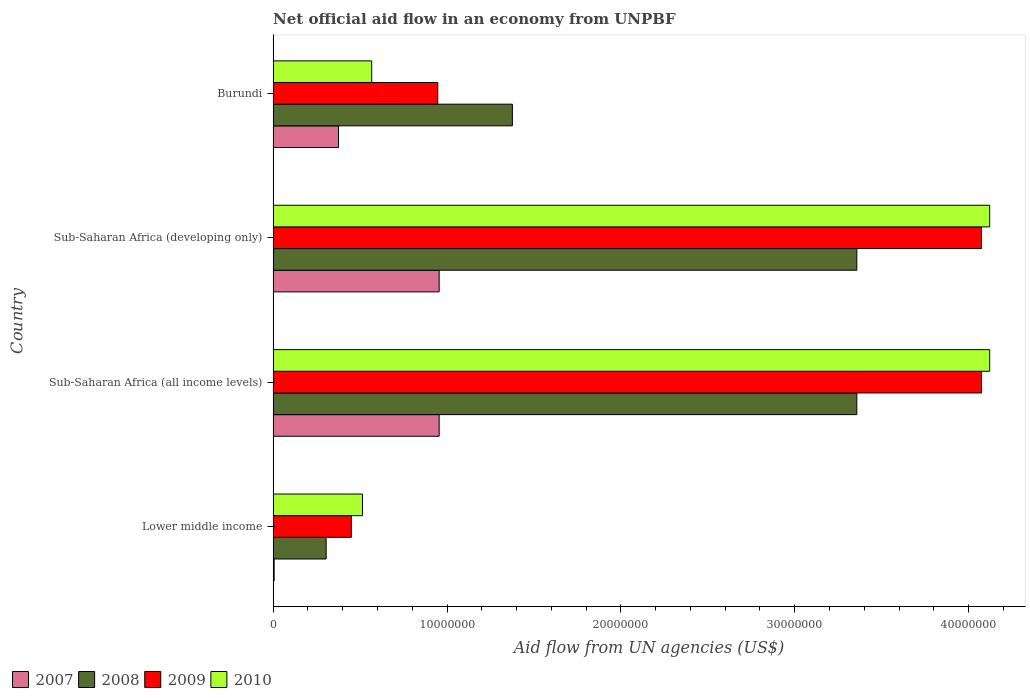How many different coloured bars are there?
Your answer should be compact. 4. How many groups of bars are there?
Offer a very short reply. 4. How many bars are there on the 2nd tick from the bottom?
Ensure brevity in your answer.  4. What is the label of the 1st group of bars from the top?
Ensure brevity in your answer.  Burundi. In how many cases, is the number of bars for a given country not equal to the number of legend labels?
Offer a very short reply. 0. What is the net official aid flow in 2010 in Lower middle income?
Your answer should be compact. 5.14e+06. Across all countries, what is the maximum net official aid flow in 2007?
Your response must be concise. 9.55e+06. Across all countries, what is the minimum net official aid flow in 2009?
Make the answer very short. 4.50e+06. In which country was the net official aid flow in 2008 maximum?
Offer a very short reply. Sub-Saharan Africa (all income levels). In which country was the net official aid flow in 2008 minimum?
Give a very brief answer. Lower middle income. What is the total net official aid flow in 2009 in the graph?
Make the answer very short. 9.54e+07. What is the difference between the net official aid flow in 2008 in Burundi and that in Lower middle income?
Offer a terse response. 1.07e+07. What is the difference between the net official aid flow in 2008 in Sub-Saharan Africa (developing only) and the net official aid flow in 2010 in Lower middle income?
Provide a succinct answer. 2.84e+07. What is the average net official aid flow in 2009 per country?
Give a very brief answer. 2.39e+07. What is the difference between the net official aid flow in 2008 and net official aid flow in 2009 in Sub-Saharan Africa (all income levels)?
Offer a very short reply. -7.17e+06. In how many countries, is the net official aid flow in 2010 greater than 34000000 US$?
Provide a short and direct response. 2. What is the ratio of the net official aid flow in 2010 in Sub-Saharan Africa (all income levels) to that in Sub-Saharan Africa (developing only)?
Keep it short and to the point. 1. What is the difference between the highest and the lowest net official aid flow in 2007?
Offer a terse response. 9.49e+06. How many countries are there in the graph?
Keep it short and to the point. 4. Where does the legend appear in the graph?
Give a very brief answer. Bottom left. How many legend labels are there?
Provide a short and direct response. 4. What is the title of the graph?
Your answer should be very brief. Net official aid flow in an economy from UNPBF. Does "1979" appear as one of the legend labels in the graph?
Your answer should be very brief. No. What is the label or title of the X-axis?
Ensure brevity in your answer.  Aid flow from UN agencies (US$). What is the Aid flow from UN agencies (US$) in 2007 in Lower middle income?
Provide a short and direct response. 6.00e+04. What is the Aid flow from UN agencies (US$) in 2008 in Lower middle income?
Your answer should be compact. 3.05e+06. What is the Aid flow from UN agencies (US$) of 2009 in Lower middle income?
Your response must be concise. 4.50e+06. What is the Aid flow from UN agencies (US$) in 2010 in Lower middle income?
Provide a short and direct response. 5.14e+06. What is the Aid flow from UN agencies (US$) in 2007 in Sub-Saharan Africa (all income levels)?
Offer a terse response. 9.55e+06. What is the Aid flow from UN agencies (US$) in 2008 in Sub-Saharan Africa (all income levels)?
Make the answer very short. 3.36e+07. What is the Aid flow from UN agencies (US$) of 2009 in Sub-Saharan Africa (all income levels)?
Offer a very short reply. 4.07e+07. What is the Aid flow from UN agencies (US$) in 2010 in Sub-Saharan Africa (all income levels)?
Give a very brief answer. 4.12e+07. What is the Aid flow from UN agencies (US$) in 2007 in Sub-Saharan Africa (developing only)?
Give a very brief answer. 9.55e+06. What is the Aid flow from UN agencies (US$) of 2008 in Sub-Saharan Africa (developing only)?
Give a very brief answer. 3.36e+07. What is the Aid flow from UN agencies (US$) in 2009 in Sub-Saharan Africa (developing only)?
Ensure brevity in your answer.  4.07e+07. What is the Aid flow from UN agencies (US$) in 2010 in Sub-Saharan Africa (developing only)?
Ensure brevity in your answer.  4.12e+07. What is the Aid flow from UN agencies (US$) in 2007 in Burundi?
Keep it short and to the point. 3.76e+06. What is the Aid flow from UN agencies (US$) in 2008 in Burundi?
Provide a short and direct response. 1.38e+07. What is the Aid flow from UN agencies (US$) in 2009 in Burundi?
Give a very brief answer. 9.47e+06. What is the Aid flow from UN agencies (US$) in 2010 in Burundi?
Keep it short and to the point. 5.67e+06. Across all countries, what is the maximum Aid flow from UN agencies (US$) in 2007?
Offer a very short reply. 9.55e+06. Across all countries, what is the maximum Aid flow from UN agencies (US$) of 2008?
Your response must be concise. 3.36e+07. Across all countries, what is the maximum Aid flow from UN agencies (US$) of 2009?
Give a very brief answer. 4.07e+07. Across all countries, what is the maximum Aid flow from UN agencies (US$) in 2010?
Your answer should be very brief. 4.12e+07. Across all countries, what is the minimum Aid flow from UN agencies (US$) of 2008?
Your response must be concise. 3.05e+06. Across all countries, what is the minimum Aid flow from UN agencies (US$) in 2009?
Offer a very short reply. 4.50e+06. Across all countries, what is the minimum Aid flow from UN agencies (US$) in 2010?
Offer a very short reply. 5.14e+06. What is the total Aid flow from UN agencies (US$) of 2007 in the graph?
Your answer should be compact. 2.29e+07. What is the total Aid flow from UN agencies (US$) of 2008 in the graph?
Ensure brevity in your answer.  8.40e+07. What is the total Aid flow from UN agencies (US$) in 2009 in the graph?
Your answer should be compact. 9.54e+07. What is the total Aid flow from UN agencies (US$) in 2010 in the graph?
Offer a very short reply. 9.32e+07. What is the difference between the Aid flow from UN agencies (US$) of 2007 in Lower middle income and that in Sub-Saharan Africa (all income levels)?
Ensure brevity in your answer.  -9.49e+06. What is the difference between the Aid flow from UN agencies (US$) in 2008 in Lower middle income and that in Sub-Saharan Africa (all income levels)?
Provide a short and direct response. -3.05e+07. What is the difference between the Aid flow from UN agencies (US$) of 2009 in Lower middle income and that in Sub-Saharan Africa (all income levels)?
Provide a succinct answer. -3.62e+07. What is the difference between the Aid flow from UN agencies (US$) of 2010 in Lower middle income and that in Sub-Saharan Africa (all income levels)?
Your answer should be very brief. -3.61e+07. What is the difference between the Aid flow from UN agencies (US$) in 2007 in Lower middle income and that in Sub-Saharan Africa (developing only)?
Offer a terse response. -9.49e+06. What is the difference between the Aid flow from UN agencies (US$) in 2008 in Lower middle income and that in Sub-Saharan Africa (developing only)?
Your answer should be compact. -3.05e+07. What is the difference between the Aid flow from UN agencies (US$) of 2009 in Lower middle income and that in Sub-Saharan Africa (developing only)?
Offer a very short reply. -3.62e+07. What is the difference between the Aid flow from UN agencies (US$) in 2010 in Lower middle income and that in Sub-Saharan Africa (developing only)?
Your response must be concise. -3.61e+07. What is the difference between the Aid flow from UN agencies (US$) in 2007 in Lower middle income and that in Burundi?
Offer a very short reply. -3.70e+06. What is the difference between the Aid flow from UN agencies (US$) in 2008 in Lower middle income and that in Burundi?
Give a very brief answer. -1.07e+07. What is the difference between the Aid flow from UN agencies (US$) of 2009 in Lower middle income and that in Burundi?
Offer a terse response. -4.97e+06. What is the difference between the Aid flow from UN agencies (US$) in 2010 in Lower middle income and that in Burundi?
Your response must be concise. -5.30e+05. What is the difference between the Aid flow from UN agencies (US$) of 2007 in Sub-Saharan Africa (all income levels) and that in Sub-Saharan Africa (developing only)?
Your answer should be very brief. 0. What is the difference between the Aid flow from UN agencies (US$) of 2007 in Sub-Saharan Africa (all income levels) and that in Burundi?
Keep it short and to the point. 5.79e+06. What is the difference between the Aid flow from UN agencies (US$) of 2008 in Sub-Saharan Africa (all income levels) and that in Burundi?
Your answer should be very brief. 1.98e+07. What is the difference between the Aid flow from UN agencies (US$) of 2009 in Sub-Saharan Africa (all income levels) and that in Burundi?
Offer a terse response. 3.13e+07. What is the difference between the Aid flow from UN agencies (US$) in 2010 in Sub-Saharan Africa (all income levels) and that in Burundi?
Provide a succinct answer. 3.55e+07. What is the difference between the Aid flow from UN agencies (US$) of 2007 in Sub-Saharan Africa (developing only) and that in Burundi?
Offer a very short reply. 5.79e+06. What is the difference between the Aid flow from UN agencies (US$) in 2008 in Sub-Saharan Africa (developing only) and that in Burundi?
Offer a very short reply. 1.98e+07. What is the difference between the Aid flow from UN agencies (US$) of 2009 in Sub-Saharan Africa (developing only) and that in Burundi?
Your answer should be very brief. 3.13e+07. What is the difference between the Aid flow from UN agencies (US$) in 2010 in Sub-Saharan Africa (developing only) and that in Burundi?
Provide a short and direct response. 3.55e+07. What is the difference between the Aid flow from UN agencies (US$) of 2007 in Lower middle income and the Aid flow from UN agencies (US$) of 2008 in Sub-Saharan Africa (all income levels)?
Ensure brevity in your answer.  -3.35e+07. What is the difference between the Aid flow from UN agencies (US$) of 2007 in Lower middle income and the Aid flow from UN agencies (US$) of 2009 in Sub-Saharan Africa (all income levels)?
Keep it short and to the point. -4.07e+07. What is the difference between the Aid flow from UN agencies (US$) in 2007 in Lower middle income and the Aid flow from UN agencies (US$) in 2010 in Sub-Saharan Africa (all income levels)?
Your answer should be compact. -4.12e+07. What is the difference between the Aid flow from UN agencies (US$) in 2008 in Lower middle income and the Aid flow from UN agencies (US$) in 2009 in Sub-Saharan Africa (all income levels)?
Make the answer very short. -3.77e+07. What is the difference between the Aid flow from UN agencies (US$) in 2008 in Lower middle income and the Aid flow from UN agencies (US$) in 2010 in Sub-Saharan Africa (all income levels)?
Make the answer very short. -3.82e+07. What is the difference between the Aid flow from UN agencies (US$) of 2009 in Lower middle income and the Aid flow from UN agencies (US$) of 2010 in Sub-Saharan Africa (all income levels)?
Offer a very short reply. -3.67e+07. What is the difference between the Aid flow from UN agencies (US$) of 2007 in Lower middle income and the Aid flow from UN agencies (US$) of 2008 in Sub-Saharan Africa (developing only)?
Provide a succinct answer. -3.35e+07. What is the difference between the Aid flow from UN agencies (US$) in 2007 in Lower middle income and the Aid flow from UN agencies (US$) in 2009 in Sub-Saharan Africa (developing only)?
Keep it short and to the point. -4.07e+07. What is the difference between the Aid flow from UN agencies (US$) in 2007 in Lower middle income and the Aid flow from UN agencies (US$) in 2010 in Sub-Saharan Africa (developing only)?
Offer a terse response. -4.12e+07. What is the difference between the Aid flow from UN agencies (US$) in 2008 in Lower middle income and the Aid flow from UN agencies (US$) in 2009 in Sub-Saharan Africa (developing only)?
Provide a succinct answer. -3.77e+07. What is the difference between the Aid flow from UN agencies (US$) of 2008 in Lower middle income and the Aid flow from UN agencies (US$) of 2010 in Sub-Saharan Africa (developing only)?
Offer a terse response. -3.82e+07. What is the difference between the Aid flow from UN agencies (US$) of 2009 in Lower middle income and the Aid flow from UN agencies (US$) of 2010 in Sub-Saharan Africa (developing only)?
Your response must be concise. -3.67e+07. What is the difference between the Aid flow from UN agencies (US$) in 2007 in Lower middle income and the Aid flow from UN agencies (US$) in 2008 in Burundi?
Make the answer very short. -1.37e+07. What is the difference between the Aid flow from UN agencies (US$) of 2007 in Lower middle income and the Aid flow from UN agencies (US$) of 2009 in Burundi?
Provide a short and direct response. -9.41e+06. What is the difference between the Aid flow from UN agencies (US$) of 2007 in Lower middle income and the Aid flow from UN agencies (US$) of 2010 in Burundi?
Provide a succinct answer. -5.61e+06. What is the difference between the Aid flow from UN agencies (US$) in 2008 in Lower middle income and the Aid flow from UN agencies (US$) in 2009 in Burundi?
Offer a terse response. -6.42e+06. What is the difference between the Aid flow from UN agencies (US$) of 2008 in Lower middle income and the Aid flow from UN agencies (US$) of 2010 in Burundi?
Make the answer very short. -2.62e+06. What is the difference between the Aid flow from UN agencies (US$) in 2009 in Lower middle income and the Aid flow from UN agencies (US$) in 2010 in Burundi?
Your response must be concise. -1.17e+06. What is the difference between the Aid flow from UN agencies (US$) in 2007 in Sub-Saharan Africa (all income levels) and the Aid flow from UN agencies (US$) in 2008 in Sub-Saharan Africa (developing only)?
Provide a short and direct response. -2.40e+07. What is the difference between the Aid flow from UN agencies (US$) of 2007 in Sub-Saharan Africa (all income levels) and the Aid flow from UN agencies (US$) of 2009 in Sub-Saharan Africa (developing only)?
Keep it short and to the point. -3.12e+07. What is the difference between the Aid flow from UN agencies (US$) of 2007 in Sub-Saharan Africa (all income levels) and the Aid flow from UN agencies (US$) of 2010 in Sub-Saharan Africa (developing only)?
Your response must be concise. -3.17e+07. What is the difference between the Aid flow from UN agencies (US$) in 2008 in Sub-Saharan Africa (all income levels) and the Aid flow from UN agencies (US$) in 2009 in Sub-Saharan Africa (developing only)?
Keep it short and to the point. -7.17e+06. What is the difference between the Aid flow from UN agencies (US$) of 2008 in Sub-Saharan Africa (all income levels) and the Aid flow from UN agencies (US$) of 2010 in Sub-Saharan Africa (developing only)?
Give a very brief answer. -7.64e+06. What is the difference between the Aid flow from UN agencies (US$) in 2009 in Sub-Saharan Africa (all income levels) and the Aid flow from UN agencies (US$) in 2010 in Sub-Saharan Africa (developing only)?
Provide a succinct answer. -4.70e+05. What is the difference between the Aid flow from UN agencies (US$) of 2007 in Sub-Saharan Africa (all income levels) and the Aid flow from UN agencies (US$) of 2008 in Burundi?
Your response must be concise. -4.21e+06. What is the difference between the Aid flow from UN agencies (US$) of 2007 in Sub-Saharan Africa (all income levels) and the Aid flow from UN agencies (US$) of 2009 in Burundi?
Give a very brief answer. 8.00e+04. What is the difference between the Aid flow from UN agencies (US$) in 2007 in Sub-Saharan Africa (all income levels) and the Aid flow from UN agencies (US$) in 2010 in Burundi?
Your response must be concise. 3.88e+06. What is the difference between the Aid flow from UN agencies (US$) in 2008 in Sub-Saharan Africa (all income levels) and the Aid flow from UN agencies (US$) in 2009 in Burundi?
Your response must be concise. 2.41e+07. What is the difference between the Aid flow from UN agencies (US$) in 2008 in Sub-Saharan Africa (all income levels) and the Aid flow from UN agencies (US$) in 2010 in Burundi?
Offer a very short reply. 2.79e+07. What is the difference between the Aid flow from UN agencies (US$) in 2009 in Sub-Saharan Africa (all income levels) and the Aid flow from UN agencies (US$) in 2010 in Burundi?
Provide a succinct answer. 3.51e+07. What is the difference between the Aid flow from UN agencies (US$) of 2007 in Sub-Saharan Africa (developing only) and the Aid flow from UN agencies (US$) of 2008 in Burundi?
Ensure brevity in your answer.  -4.21e+06. What is the difference between the Aid flow from UN agencies (US$) of 2007 in Sub-Saharan Africa (developing only) and the Aid flow from UN agencies (US$) of 2009 in Burundi?
Offer a very short reply. 8.00e+04. What is the difference between the Aid flow from UN agencies (US$) in 2007 in Sub-Saharan Africa (developing only) and the Aid flow from UN agencies (US$) in 2010 in Burundi?
Offer a terse response. 3.88e+06. What is the difference between the Aid flow from UN agencies (US$) in 2008 in Sub-Saharan Africa (developing only) and the Aid flow from UN agencies (US$) in 2009 in Burundi?
Make the answer very short. 2.41e+07. What is the difference between the Aid flow from UN agencies (US$) of 2008 in Sub-Saharan Africa (developing only) and the Aid flow from UN agencies (US$) of 2010 in Burundi?
Offer a very short reply. 2.79e+07. What is the difference between the Aid flow from UN agencies (US$) of 2009 in Sub-Saharan Africa (developing only) and the Aid flow from UN agencies (US$) of 2010 in Burundi?
Offer a very short reply. 3.51e+07. What is the average Aid flow from UN agencies (US$) of 2007 per country?
Offer a very short reply. 5.73e+06. What is the average Aid flow from UN agencies (US$) of 2008 per country?
Make the answer very short. 2.10e+07. What is the average Aid flow from UN agencies (US$) in 2009 per country?
Make the answer very short. 2.39e+07. What is the average Aid flow from UN agencies (US$) of 2010 per country?
Provide a succinct answer. 2.33e+07. What is the difference between the Aid flow from UN agencies (US$) of 2007 and Aid flow from UN agencies (US$) of 2008 in Lower middle income?
Give a very brief answer. -2.99e+06. What is the difference between the Aid flow from UN agencies (US$) in 2007 and Aid flow from UN agencies (US$) in 2009 in Lower middle income?
Give a very brief answer. -4.44e+06. What is the difference between the Aid flow from UN agencies (US$) of 2007 and Aid flow from UN agencies (US$) of 2010 in Lower middle income?
Keep it short and to the point. -5.08e+06. What is the difference between the Aid flow from UN agencies (US$) of 2008 and Aid flow from UN agencies (US$) of 2009 in Lower middle income?
Make the answer very short. -1.45e+06. What is the difference between the Aid flow from UN agencies (US$) of 2008 and Aid flow from UN agencies (US$) of 2010 in Lower middle income?
Keep it short and to the point. -2.09e+06. What is the difference between the Aid flow from UN agencies (US$) of 2009 and Aid flow from UN agencies (US$) of 2010 in Lower middle income?
Your answer should be compact. -6.40e+05. What is the difference between the Aid flow from UN agencies (US$) of 2007 and Aid flow from UN agencies (US$) of 2008 in Sub-Saharan Africa (all income levels)?
Give a very brief answer. -2.40e+07. What is the difference between the Aid flow from UN agencies (US$) in 2007 and Aid flow from UN agencies (US$) in 2009 in Sub-Saharan Africa (all income levels)?
Provide a succinct answer. -3.12e+07. What is the difference between the Aid flow from UN agencies (US$) of 2007 and Aid flow from UN agencies (US$) of 2010 in Sub-Saharan Africa (all income levels)?
Your response must be concise. -3.17e+07. What is the difference between the Aid flow from UN agencies (US$) in 2008 and Aid flow from UN agencies (US$) in 2009 in Sub-Saharan Africa (all income levels)?
Keep it short and to the point. -7.17e+06. What is the difference between the Aid flow from UN agencies (US$) in 2008 and Aid flow from UN agencies (US$) in 2010 in Sub-Saharan Africa (all income levels)?
Offer a terse response. -7.64e+06. What is the difference between the Aid flow from UN agencies (US$) of 2009 and Aid flow from UN agencies (US$) of 2010 in Sub-Saharan Africa (all income levels)?
Your answer should be very brief. -4.70e+05. What is the difference between the Aid flow from UN agencies (US$) in 2007 and Aid flow from UN agencies (US$) in 2008 in Sub-Saharan Africa (developing only)?
Keep it short and to the point. -2.40e+07. What is the difference between the Aid flow from UN agencies (US$) in 2007 and Aid flow from UN agencies (US$) in 2009 in Sub-Saharan Africa (developing only)?
Offer a very short reply. -3.12e+07. What is the difference between the Aid flow from UN agencies (US$) in 2007 and Aid flow from UN agencies (US$) in 2010 in Sub-Saharan Africa (developing only)?
Your answer should be compact. -3.17e+07. What is the difference between the Aid flow from UN agencies (US$) of 2008 and Aid flow from UN agencies (US$) of 2009 in Sub-Saharan Africa (developing only)?
Give a very brief answer. -7.17e+06. What is the difference between the Aid flow from UN agencies (US$) in 2008 and Aid flow from UN agencies (US$) in 2010 in Sub-Saharan Africa (developing only)?
Your answer should be very brief. -7.64e+06. What is the difference between the Aid flow from UN agencies (US$) in 2009 and Aid flow from UN agencies (US$) in 2010 in Sub-Saharan Africa (developing only)?
Provide a short and direct response. -4.70e+05. What is the difference between the Aid flow from UN agencies (US$) in 2007 and Aid flow from UN agencies (US$) in 2008 in Burundi?
Your response must be concise. -1.00e+07. What is the difference between the Aid flow from UN agencies (US$) of 2007 and Aid flow from UN agencies (US$) of 2009 in Burundi?
Provide a short and direct response. -5.71e+06. What is the difference between the Aid flow from UN agencies (US$) of 2007 and Aid flow from UN agencies (US$) of 2010 in Burundi?
Offer a terse response. -1.91e+06. What is the difference between the Aid flow from UN agencies (US$) in 2008 and Aid flow from UN agencies (US$) in 2009 in Burundi?
Your response must be concise. 4.29e+06. What is the difference between the Aid flow from UN agencies (US$) of 2008 and Aid flow from UN agencies (US$) of 2010 in Burundi?
Ensure brevity in your answer.  8.09e+06. What is the difference between the Aid flow from UN agencies (US$) of 2009 and Aid flow from UN agencies (US$) of 2010 in Burundi?
Ensure brevity in your answer.  3.80e+06. What is the ratio of the Aid flow from UN agencies (US$) in 2007 in Lower middle income to that in Sub-Saharan Africa (all income levels)?
Your response must be concise. 0.01. What is the ratio of the Aid flow from UN agencies (US$) in 2008 in Lower middle income to that in Sub-Saharan Africa (all income levels)?
Provide a short and direct response. 0.09. What is the ratio of the Aid flow from UN agencies (US$) in 2009 in Lower middle income to that in Sub-Saharan Africa (all income levels)?
Your answer should be very brief. 0.11. What is the ratio of the Aid flow from UN agencies (US$) in 2010 in Lower middle income to that in Sub-Saharan Africa (all income levels)?
Offer a terse response. 0.12. What is the ratio of the Aid flow from UN agencies (US$) of 2007 in Lower middle income to that in Sub-Saharan Africa (developing only)?
Your answer should be compact. 0.01. What is the ratio of the Aid flow from UN agencies (US$) in 2008 in Lower middle income to that in Sub-Saharan Africa (developing only)?
Your response must be concise. 0.09. What is the ratio of the Aid flow from UN agencies (US$) in 2009 in Lower middle income to that in Sub-Saharan Africa (developing only)?
Provide a short and direct response. 0.11. What is the ratio of the Aid flow from UN agencies (US$) of 2010 in Lower middle income to that in Sub-Saharan Africa (developing only)?
Provide a succinct answer. 0.12. What is the ratio of the Aid flow from UN agencies (US$) of 2007 in Lower middle income to that in Burundi?
Ensure brevity in your answer.  0.02. What is the ratio of the Aid flow from UN agencies (US$) in 2008 in Lower middle income to that in Burundi?
Your response must be concise. 0.22. What is the ratio of the Aid flow from UN agencies (US$) of 2009 in Lower middle income to that in Burundi?
Make the answer very short. 0.48. What is the ratio of the Aid flow from UN agencies (US$) of 2010 in Lower middle income to that in Burundi?
Your answer should be very brief. 0.91. What is the ratio of the Aid flow from UN agencies (US$) in 2009 in Sub-Saharan Africa (all income levels) to that in Sub-Saharan Africa (developing only)?
Your answer should be very brief. 1. What is the ratio of the Aid flow from UN agencies (US$) in 2007 in Sub-Saharan Africa (all income levels) to that in Burundi?
Offer a very short reply. 2.54. What is the ratio of the Aid flow from UN agencies (US$) in 2008 in Sub-Saharan Africa (all income levels) to that in Burundi?
Provide a succinct answer. 2.44. What is the ratio of the Aid flow from UN agencies (US$) in 2009 in Sub-Saharan Africa (all income levels) to that in Burundi?
Offer a very short reply. 4.3. What is the ratio of the Aid flow from UN agencies (US$) in 2010 in Sub-Saharan Africa (all income levels) to that in Burundi?
Give a very brief answer. 7.27. What is the ratio of the Aid flow from UN agencies (US$) of 2007 in Sub-Saharan Africa (developing only) to that in Burundi?
Offer a terse response. 2.54. What is the ratio of the Aid flow from UN agencies (US$) of 2008 in Sub-Saharan Africa (developing only) to that in Burundi?
Give a very brief answer. 2.44. What is the ratio of the Aid flow from UN agencies (US$) of 2009 in Sub-Saharan Africa (developing only) to that in Burundi?
Provide a short and direct response. 4.3. What is the ratio of the Aid flow from UN agencies (US$) of 2010 in Sub-Saharan Africa (developing only) to that in Burundi?
Keep it short and to the point. 7.27. What is the difference between the highest and the second highest Aid flow from UN agencies (US$) of 2008?
Offer a very short reply. 0. What is the difference between the highest and the second highest Aid flow from UN agencies (US$) in 2010?
Provide a succinct answer. 0. What is the difference between the highest and the lowest Aid flow from UN agencies (US$) in 2007?
Your answer should be compact. 9.49e+06. What is the difference between the highest and the lowest Aid flow from UN agencies (US$) of 2008?
Provide a succinct answer. 3.05e+07. What is the difference between the highest and the lowest Aid flow from UN agencies (US$) of 2009?
Offer a terse response. 3.62e+07. What is the difference between the highest and the lowest Aid flow from UN agencies (US$) of 2010?
Give a very brief answer. 3.61e+07. 